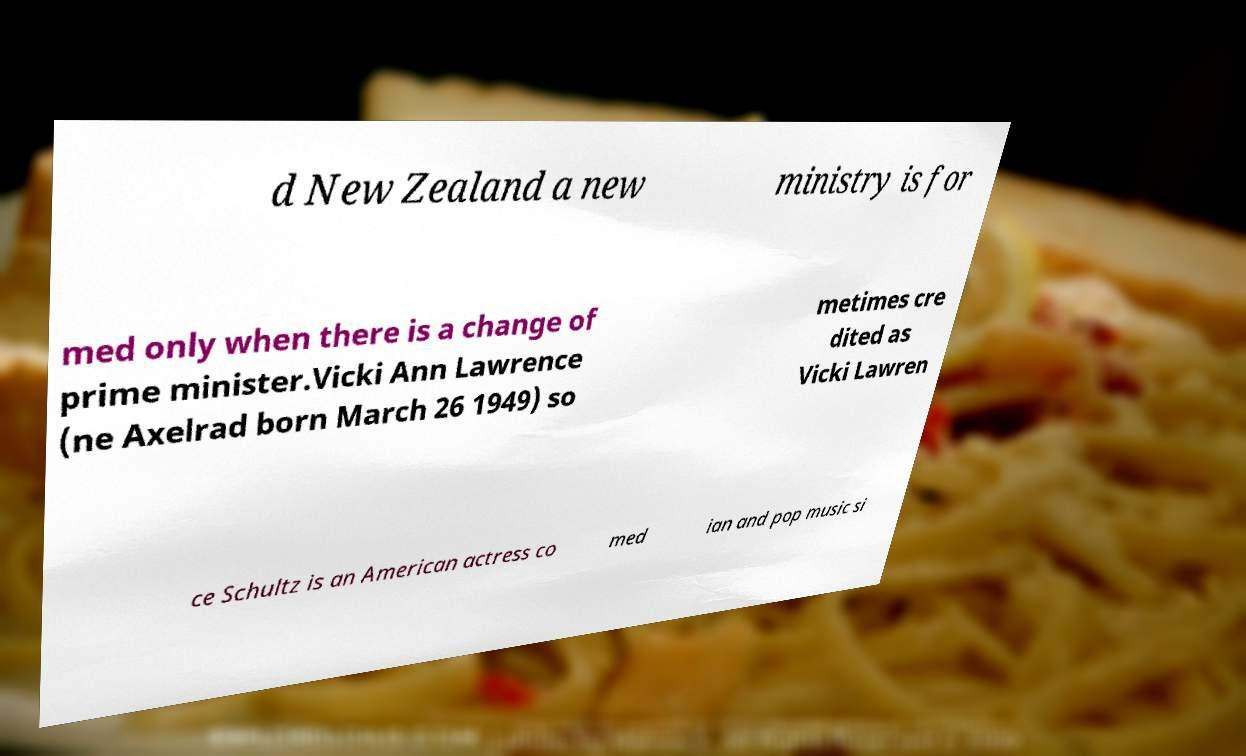I need the written content from this picture converted into text. Can you do that? d New Zealand a new ministry is for med only when there is a change of prime minister.Vicki Ann Lawrence (ne Axelrad born March 26 1949) so metimes cre dited as Vicki Lawren ce Schultz is an American actress co med ian and pop music si 